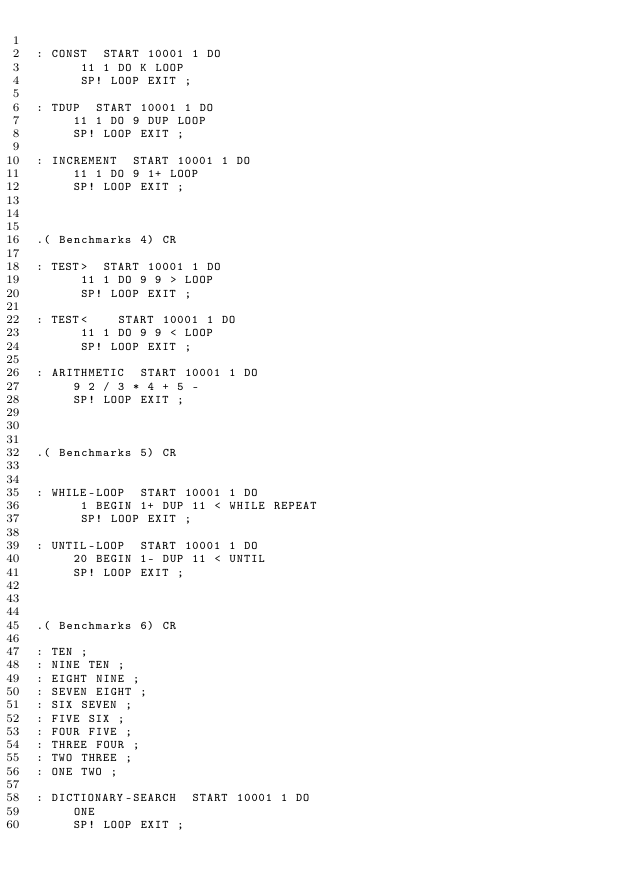Convert code to text. <code><loc_0><loc_0><loc_500><loc_500><_Forth_>
: CONST  START 10001 1 DO
      11 1 DO K LOOP
      SP! LOOP EXIT ;

: TDUP  START 10001 1 DO
     11 1 DO 9 DUP LOOP
     SP! LOOP EXIT ;

: INCREMENT  START 10001 1 DO
     11 1 DO 9 1+ LOOP
     SP! LOOP EXIT ;



.( Benchmarks 4) CR

: TEST>  START 10001 1 DO
      11 1 DO 9 9 > LOOP
      SP! LOOP EXIT ;

: TEST<    START 10001 1 DO
      11 1 DO 9 9 < LOOP
      SP! LOOP EXIT ;

: ARITHMETIC  START 10001 1 DO
     9 2 / 3 * 4 + 5 -
     SP! LOOP EXIT ;



.( Benchmarks 5) CR


: WHILE-LOOP  START 10001 1 DO
      1 BEGIN 1+ DUP 11 < WHILE REPEAT
      SP! LOOP EXIT ;

: UNTIL-LOOP  START 10001 1 DO
     20 BEGIN 1- DUP 11 < UNTIL
     SP! LOOP EXIT ;



.( Benchmarks 6) CR

: TEN ;
: NINE TEN ;
: EIGHT NINE ;
: SEVEN EIGHT ;
: SIX SEVEN ;
: FIVE SIX ;
: FOUR FIVE ;
: THREE FOUR ;
: TWO THREE ;
: ONE TWO ;

: DICTIONARY-SEARCH  START 10001 1 DO
     ONE
     SP! LOOP EXIT ;
</code> 